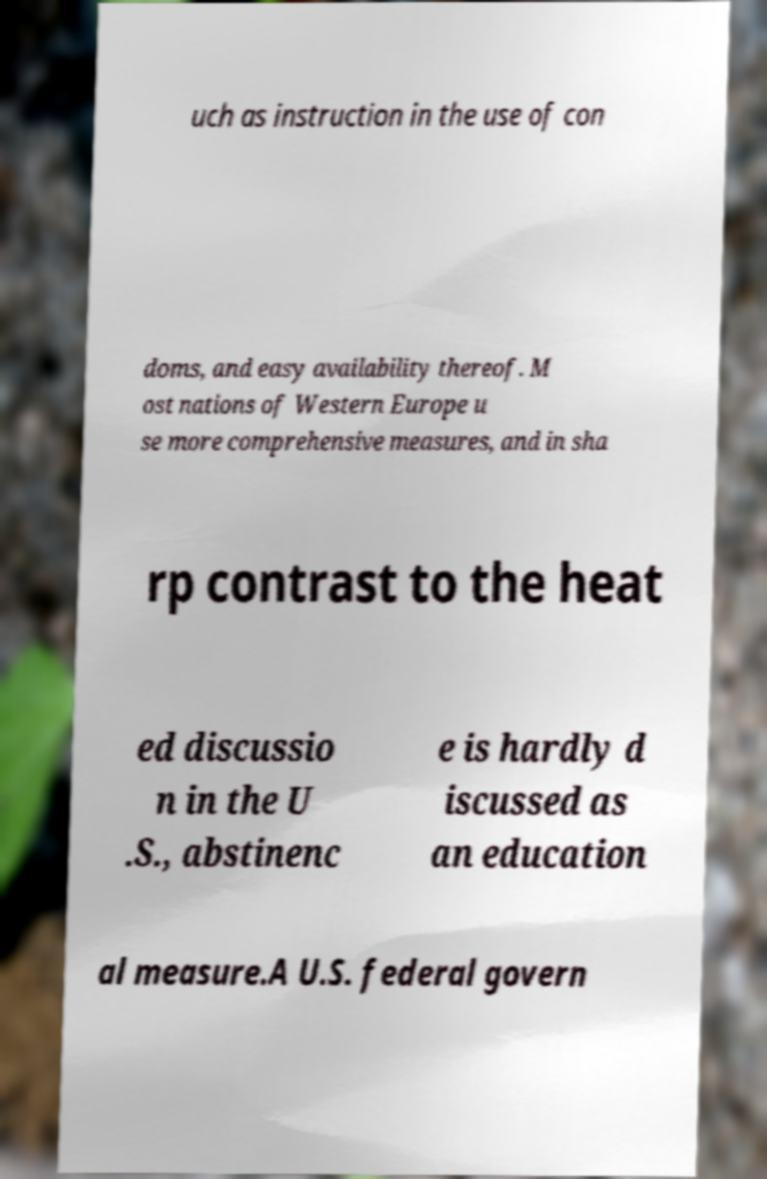Please identify and transcribe the text found in this image. uch as instruction in the use of con doms, and easy availability thereof. M ost nations of Western Europe u se more comprehensive measures, and in sha rp contrast to the heat ed discussio n in the U .S., abstinenc e is hardly d iscussed as an education al measure.A U.S. federal govern 